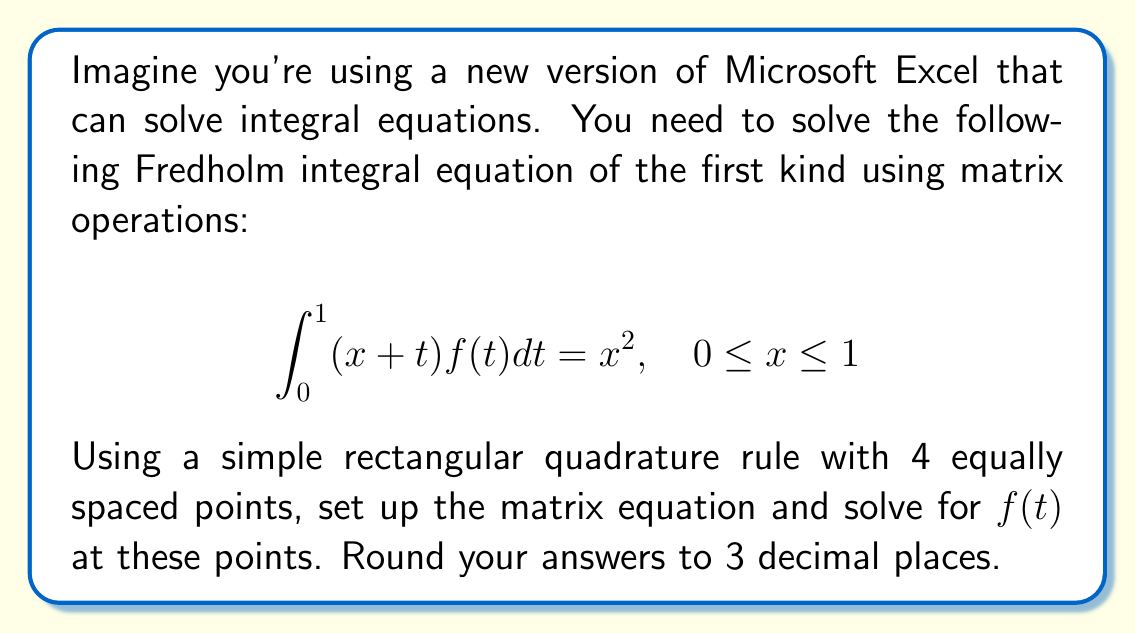What is the answer to this math problem? Let's solve this step-by-step using a method similar to how Excel might approach it:

1) First, we divide the interval [0,1] into 4 equal parts. The points are:
   $t_1 = 0, t_2 = 0.25, t_3 = 0.5, t_4 = 0.75, t_5 = 1$

2) We'll use the midpoints of these intervals for our quadrature:
   $t_1 = 0.125, t_2 = 0.375, t_3 = 0.625, t_4 = 0.875$

3) The rectangular quadrature rule approximates the integral as:

   $$\int_{0}^{1} (x+t)f(t)dt \approx 0.25 \sum_{i=1}^{4} (x+t_i)f(t_i)$$

4) We need to satisfy the equation at 4 points. Let's use $x_1 = 0.125, x_2 = 0.375, x_3 = 0.625, x_4 = 0.875$

5) This gives us a system of linear equations:

   $$0.25 \sum_{i=1}^{4} (x_j+t_i)f(t_i) = x_j^2, \quad j = 1,2,3,4$$

6) We can write this as a matrix equation $Af = b$, where:

   $$A = 0.25 \begin{pmatrix} 
   0.25 & 0.5 & 0.75 & 1.0 \\
   0.5 & 0.75 & 1.0 & 1.25 \\
   0.75 & 1.0 & 1.25 & 1.5 \\
   1.0 & 1.25 & 1.5 & 1.75
   \end{pmatrix}$$

   $$b = \begin{pmatrix} 
   0.015625 \\
   0.140625 \\
   0.390625 \\
   0.765625
   \end{pmatrix}$$

7) To solve for $f$, we compute $f = A^{-1}b$. Using a calculator or computer (like Excel), we get:

   $$f \approx \begin{pmatrix} 
   -0.533 \\
   1.600 \\
   -1.600 \\
   1.533
   \end{pmatrix}$$

Thus, our approximation for $f(t)$ at the four points is:
$f(0.125) \approx -0.533$
$f(0.375) \approx 1.600$
$f(0.625) \approx -1.600$
$f(0.875) \approx 1.533$
Answer: $f(t) \approx (-0.533, 1.600, -1.600, 1.533)$ at $t = (0.125, 0.375, 0.625, 0.875)$ 